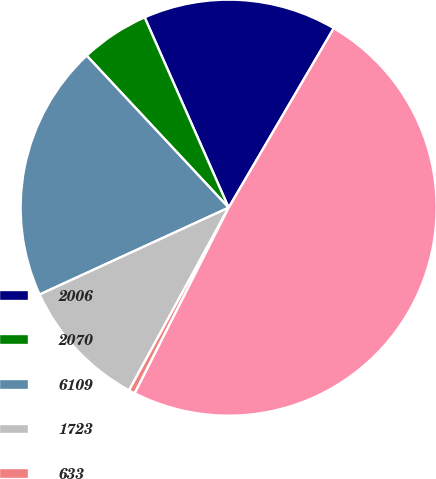<chart> <loc_0><loc_0><loc_500><loc_500><pie_chart><fcel>2006<fcel>2070<fcel>6109<fcel>1723<fcel>633<fcel>31760<nl><fcel>15.05%<fcel>5.34%<fcel>19.9%<fcel>10.2%<fcel>0.49%<fcel>49.02%<nl></chart> 